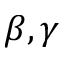<formula> <loc_0><loc_0><loc_500><loc_500>\beta , \gamma</formula> 